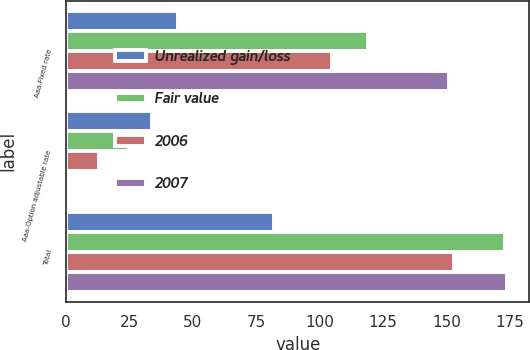<chart> <loc_0><loc_0><loc_500><loc_500><stacked_bar_chart><ecel><fcel>Aaa-Fixed rate<fcel>Aaa-Option adjustable rate<fcel>Total<nl><fcel>Unrealized gain/loss<fcel>44<fcel>34<fcel>82<nl><fcel>Fair value<fcel>119<fcel>25<fcel>173<nl><fcel>2006<fcel>105<fcel>13<fcel>153<nl><fcel>2007<fcel>151<fcel>1<fcel>174<nl></chart> 